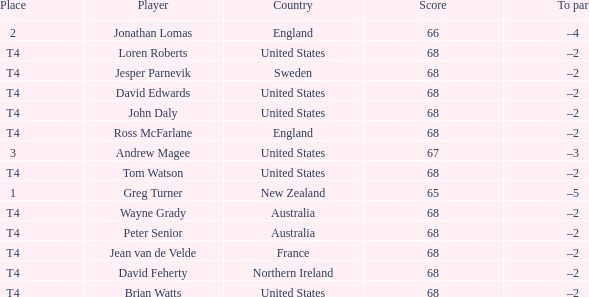Who has a To par of –2, and a Country of united states? John Daly, David Edwards, Loren Roberts, Tom Watson, Brian Watts. 